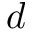Convert formula to latex. <formula><loc_0><loc_0><loc_500><loc_500>d</formula> 